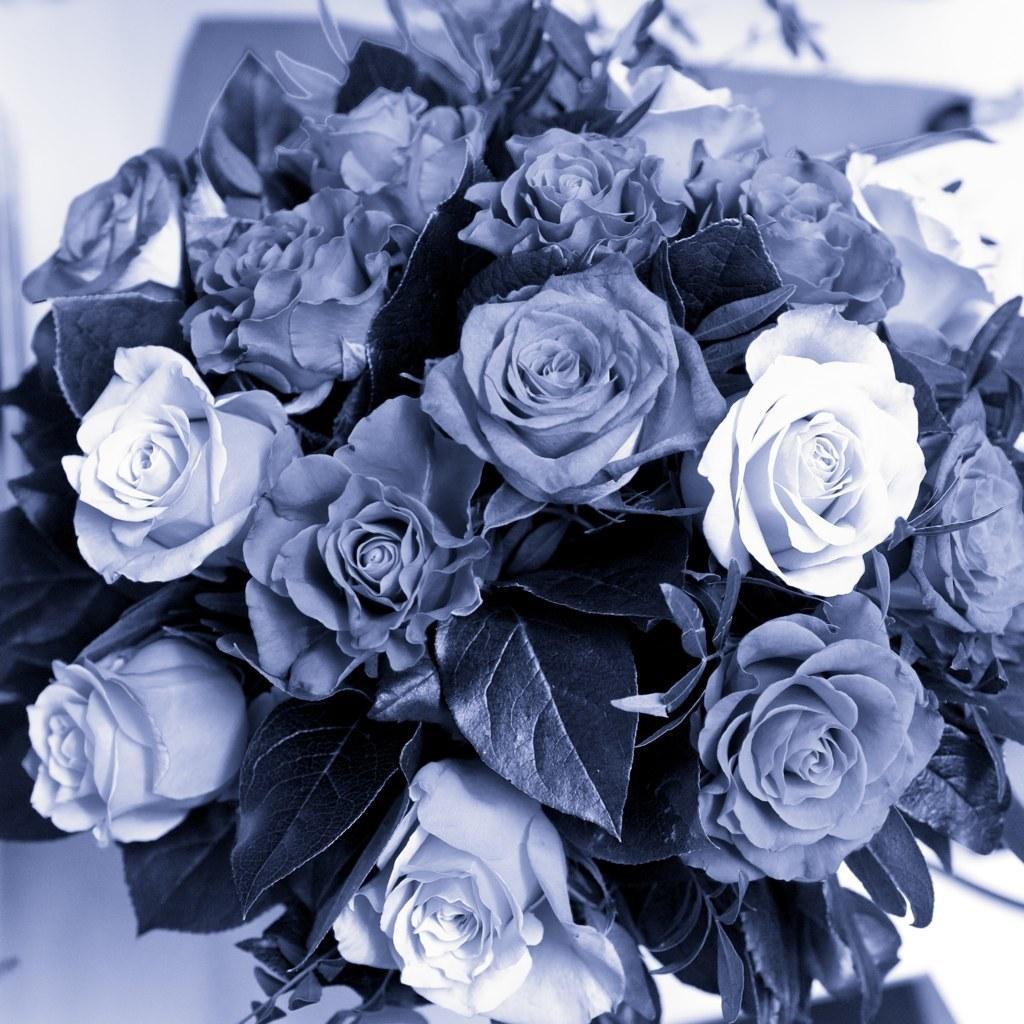Please provide a concise description of this image. In this picture we can see some rose flowers and leaves. 